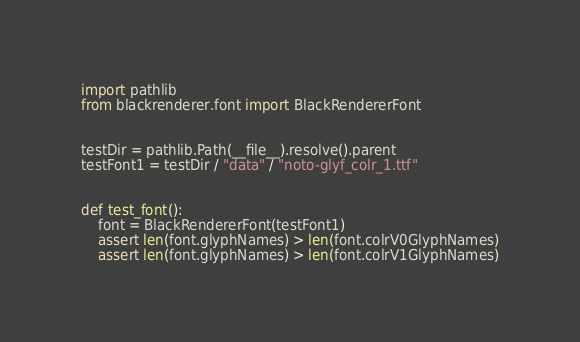Convert code to text. <code><loc_0><loc_0><loc_500><loc_500><_Python_>import pathlib
from blackrenderer.font import BlackRendererFont


testDir = pathlib.Path(__file__).resolve().parent
testFont1 = testDir / "data" / "noto-glyf_colr_1.ttf"


def test_font():
    font = BlackRendererFont(testFont1)
    assert len(font.glyphNames) > len(font.colrV0GlyphNames)
    assert len(font.glyphNames) > len(font.colrV1GlyphNames)
</code> 